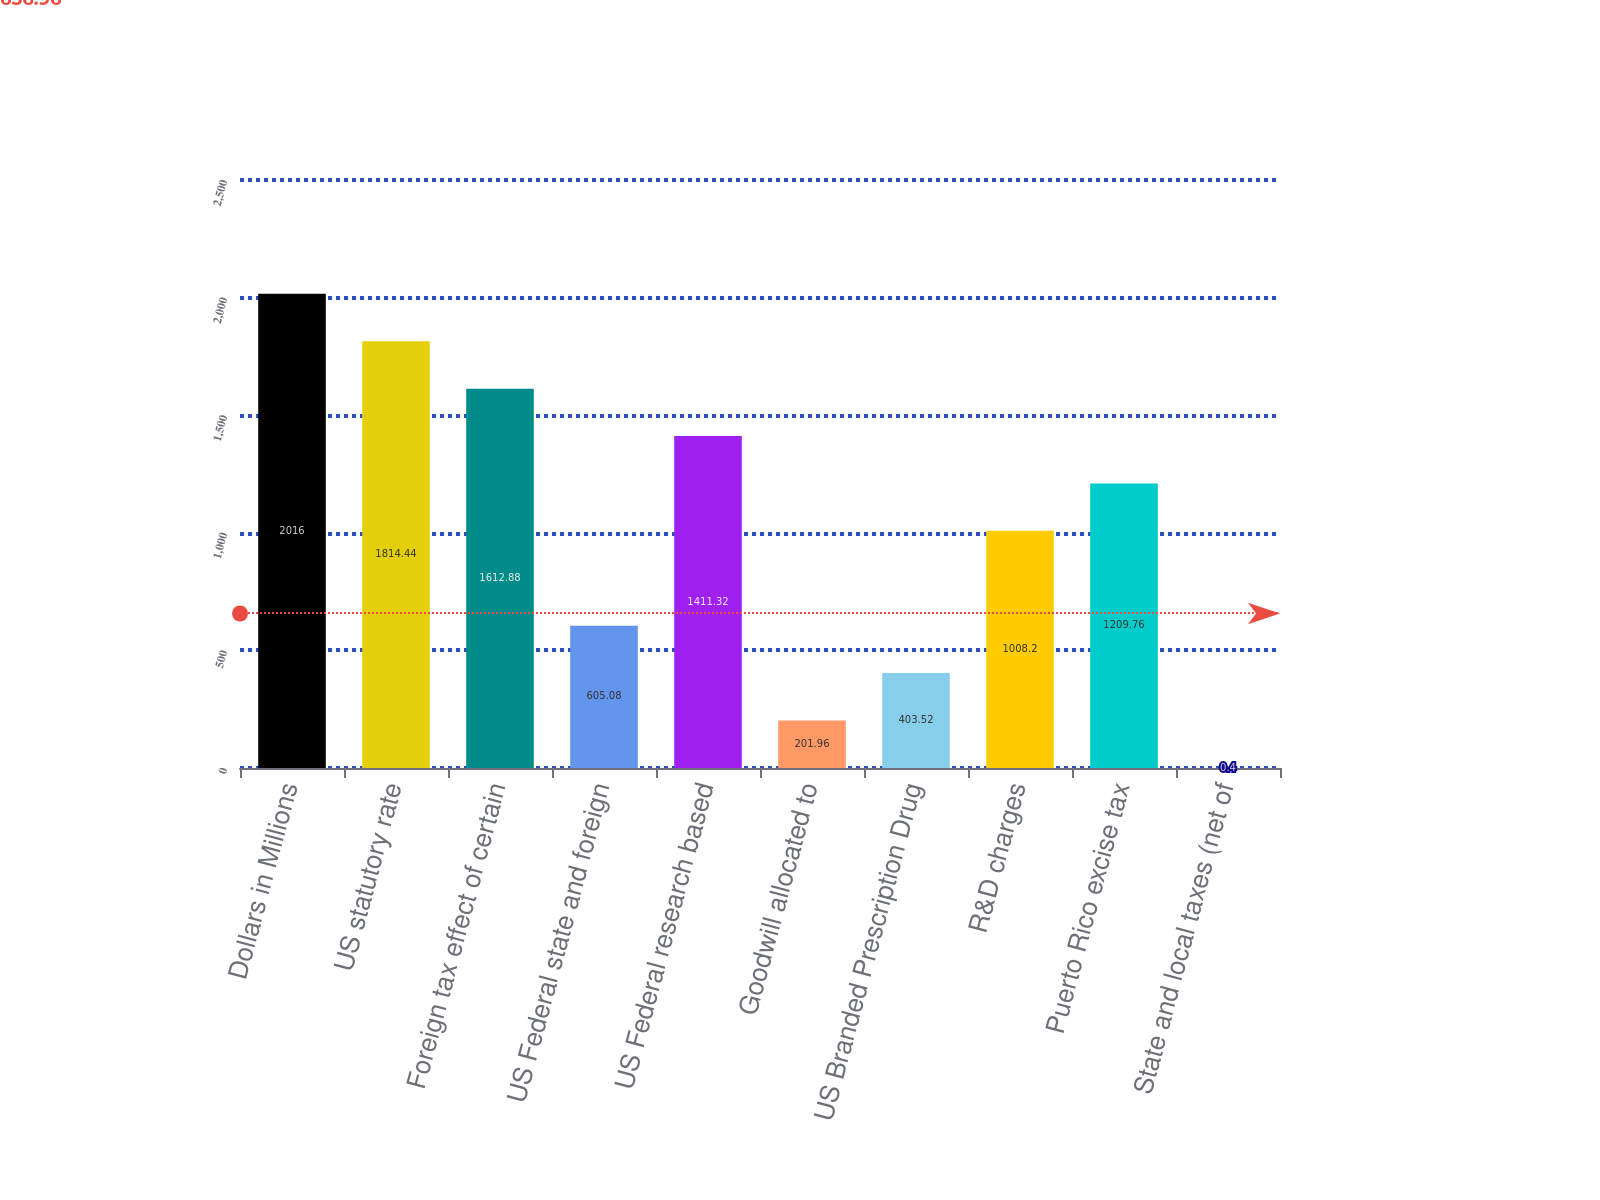<chart> <loc_0><loc_0><loc_500><loc_500><bar_chart><fcel>Dollars in Millions<fcel>US statutory rate<fcel>Foreign tax effect of certain<fcel>US Federal state and foreign<fcel>US Federal research based<fcel>Goodwill allocated to<fcel>US Branded Prescription Drug<fcel>R&D charges<fcel>Puerto Rico excise tax<fcel>State and local taxes (net of<nl><fcel>2016<fcel>1814.44<fcel>1612.88<fcel>605.08<fcel>1411.32<fcel>201.96<fcel>403.52<fcel>1008.2<fcel>1209.76<fcel>0.4<nl></chart> 